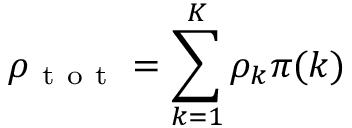<formula> <loc_0><loc_0><loc_500><loc_500>\rho _ { t o t } = \sum _ { k = 1 } ^ { K } \rho _ { k } \pi ( k )</formula> 